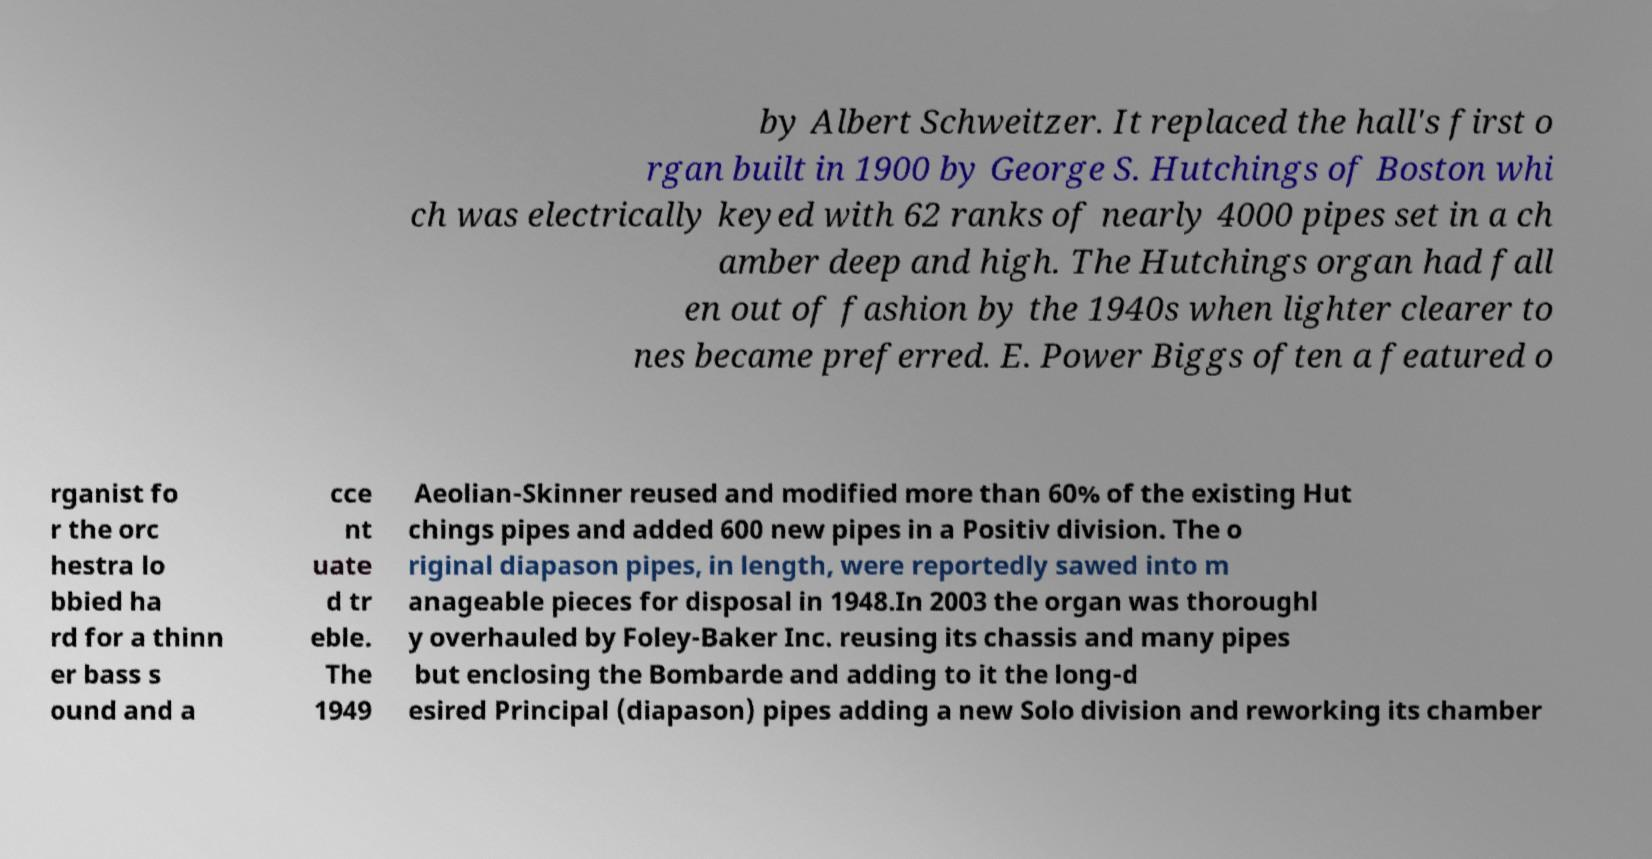There's text embedded in this image that I need extracted. Can you transcribe it verbatim? by Albert Schweitzer. It replaced the hall's first o rgan built in 1900 by George S. Hutchings of Boston whi ch was electrically keyed with 62 ranks of nearly 4000 pipes set in a ch amber deep and high. The Hutchings organ had fall en out of fashion by the 1940s when lighter clearer to nes became preferred. E. Power Biggs often a featured o rganist fo r the orc hestra lo bbied ha rd for a thinn er bass s ound and a cce nt uate d tr eble. The 1949 Aeolian-Skinner reused and modified more than 60% of the existing Hut chings pipes and added 600 new pipes in a Positiv division. The o riginal diapason pipes, in length, were reportedly sawed into m anageable pieces for disposal in 1948.In 2003 the organ was thoroughl y overhauled by Foley-Baker Inc. reusing its chassis and many pipes but enclosing the Bombarde and adding to it the long-d esired Principal (diapason) pipes adding a new Solo division and reworking its chamber 